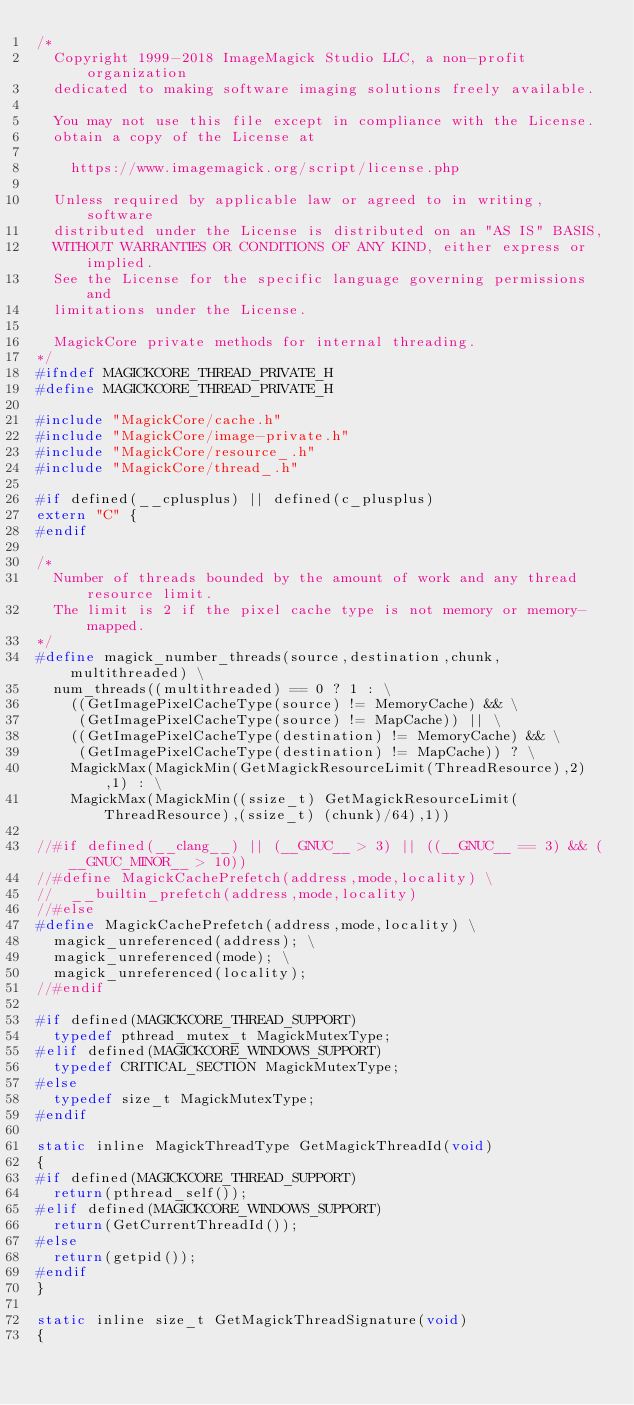<code> <loc_0><loc_0><loc_500><loc_500><_C_>/*
  Copyright 1999-2018 ImageMagick Studio LLC, a non-profit organization
  dedicated to making software imaging solutions freely available.

  You may not use this file except in compliance with the License.
  obtain a copy of the License at

    https://www.imagemagick.org/script/license.php

  Unless required by applicable law or agreed to in writing, software
  distributed under the License is distributed on an "AS IS" BASIS,
  WITHOUT WARRANTIES OR CONDITIONS OF ANY KIND, either express or implied.
  See the License for the specific language governing permissions and
  limitations under the License.

  MagickCore private methods for internal threading.
*/
#ifndef MAGICKCORE_THREAD_PRIVATE_H
#define MAGICKCORE_THREAD_PRIVATE_H

#include "MagickCore/cache.h"
#include "MagickCore/image-private.h"
#include "MagickCore/resource_.h"
#include "MagickCore/thread_.h"

#if defined(__cplusplus) || defined(c_plusplus)
extern "C" {
#endif

/*
  Number of threads bounded by the amount of work and any thread resource limit.
  The limit is 2 if the pixel cache type is not memory or memory-mapped.
*/
#define magick_number_threads(source,destination,chunk,multithreaded) \
  num_threads((multithreaded) == 0 ? 1 : \
    ((GetImagePixelCacheType(source) != MemoryCache) && \
     (GetImagePixelCacheType(source) != MapCache)) || \
    ((GetImagePixelCacheType(destination) != MemoryCache) && \
     (GetImagePixelCacheType(destination) != MapCache)) ? \
    MagickMax(MagickMin(GetMagickResourceLimit(ThreadResource),2),1) : \
    MagickMax(MagickMin((ssize_t) GetMagickResourceLimit(ThreadResource),(ssize_t) (chunk)/64),1))

//#if defined(__clang__) || (__GNUC__ > 3) || ((__GNUC__ == 3) && (__GNUC_MINOR__ > 10))
//#define MagickCachePrefetch(address,mode,locality) \
//  __builtin_prefetch(address,mode,locality)
//#else
#define MagickCachePrefetch(address,mode,locality) \
  magick_unreferenced(address); \
  magick_unreferenced(mode); \
  magick_unreferenced(locality);
//#endif

#if defined(MAGICKCORE_THREAD_SUPPORT)
  typedef pthread_mutex_t MagickMutexType;
#elif defined(MAGICKCORE_WINDOWS_SUPPORT)
  typedef CRITICAL_SECTION MagickMutexType;
#else
  typedef size_t MagickMutexType;
#endif

static inline MagickThreadType GetMagickThreadId(void)
{
#if defined(MAGICKCORE_THREAD_SUPPORT)
  return(pthread_self());
#elif defined(MAGICKCORE_WINDOWS_SUPPORT)
  return(GetCurrentThreadId());
#else
  return(getpid());
#endif
}

static inline size_t GetMagickThreadSignature(void)
{</code> 